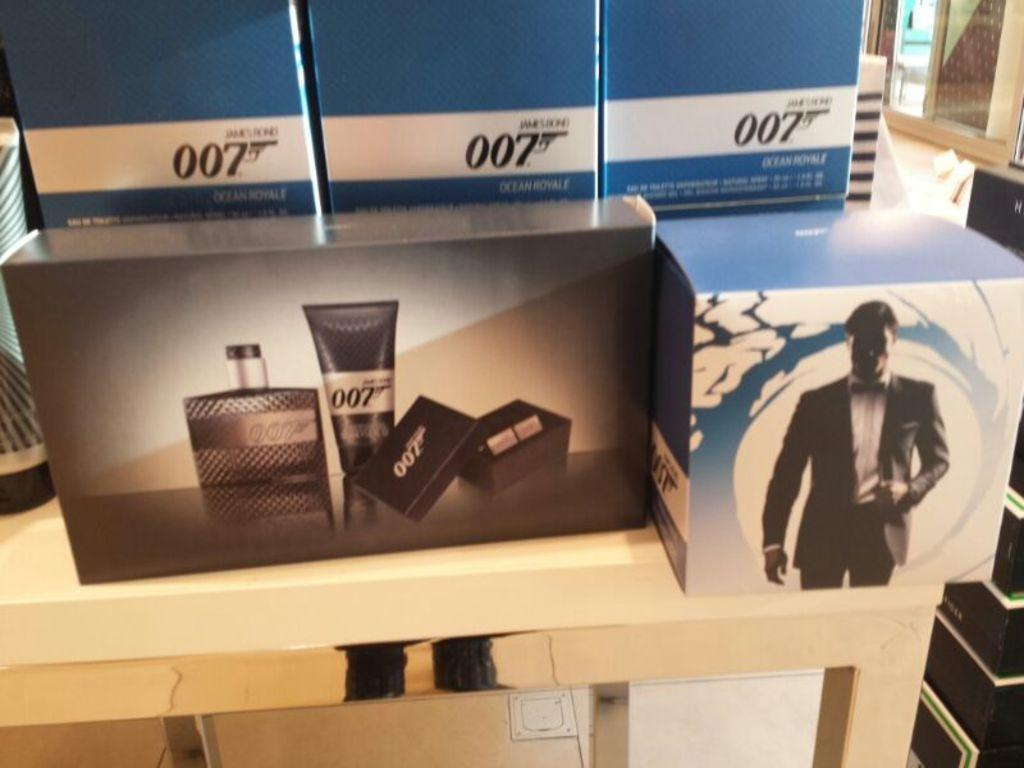What is the main piece of furniture in the image? There is a table in the image. What is placed on the table? There are boxes on the table. Can you describe the window in the image? There is a window in the top right corner of the image. What type of notebook is the father using in the image? There is no father or notebook present in the image. 